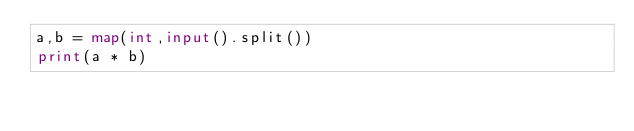<code> <loc_0><loc_0><loc_500><loc_500><_Python_>a,b = map(int,input().split())
print(a * b)</code> 